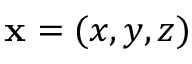Convert formula to latex. <formula><loc_0><loc_0><loc_500><loc_500>x = ( x , y , z )</formula> 